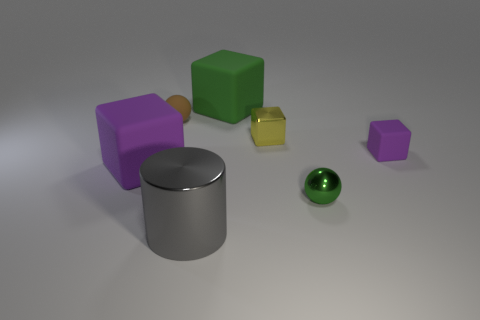There is a sphere to the right of the yellow object left of the purple block that is right of the big green rubber block; what size is it?
Keep it short and to the point. Small. How many tiny shiny balls are the same color as the rubber ball?
Give a very brief answer. 0. How many objects are either large green blocks or objects that are on the left side of the metal sphere?
Offer a very short reply. 5. What is the color of the big metal object?
Your answer should be compact. Gray. What is the color of the rubber block that is on the right side of the large green matte block?
Your answer should be very brief. Purple. What number of green matte things are to the right of the green object that is behind the tiny purple cube?
Your response must be concise. 0. Is the size of the gray object the same as the cube on the left side of the big cylinder?
Your response must be concise. Yes. Is there a blue ball of the same size as the gray shiny thing?
Offer a terse response. No. How many things are small green metallic spheres or small brown rubber cylinders?
Your answer should be very brief. 1. There is a purple object that is to the right of the gray shiny thing; is its size the same as the purple matte cube that is in front of the tiny purple matte cube?
Make the answer very short. No. 